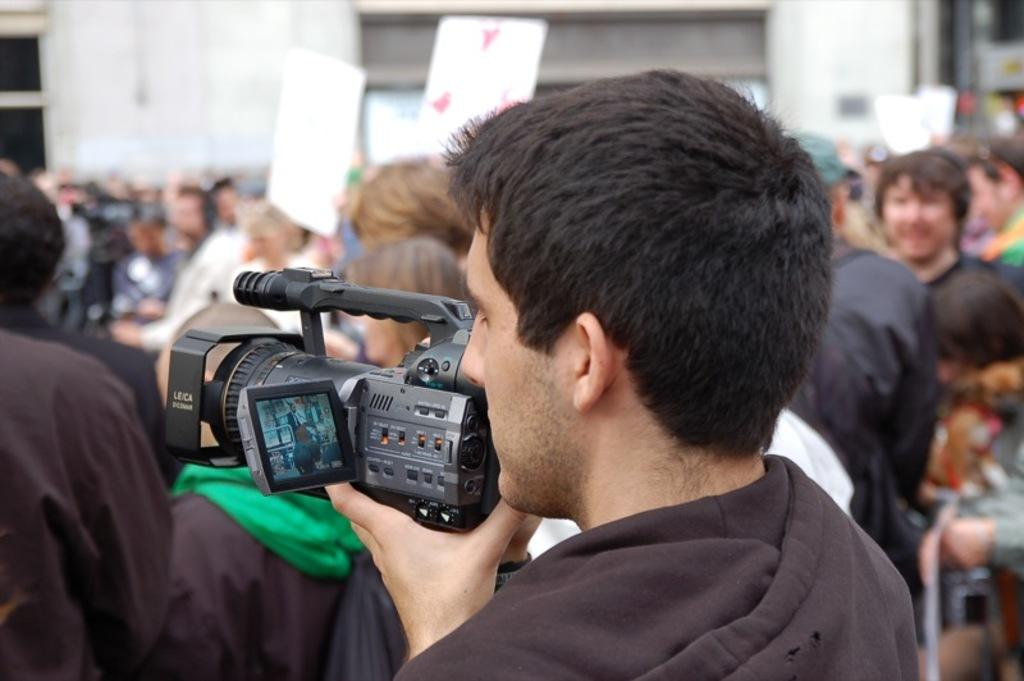What is the man in the foreground of the image doing? The man is holding a camera in the foreground of the image. What can be seen in the background of the image? There is a group of persons in the background of the image. What architectural feature is visible at the top of the image? There is a building wall visible at the top of the image. How many spiders can be seen crawling on the cave wall in the image? There is no cave or spiders present in the image. 